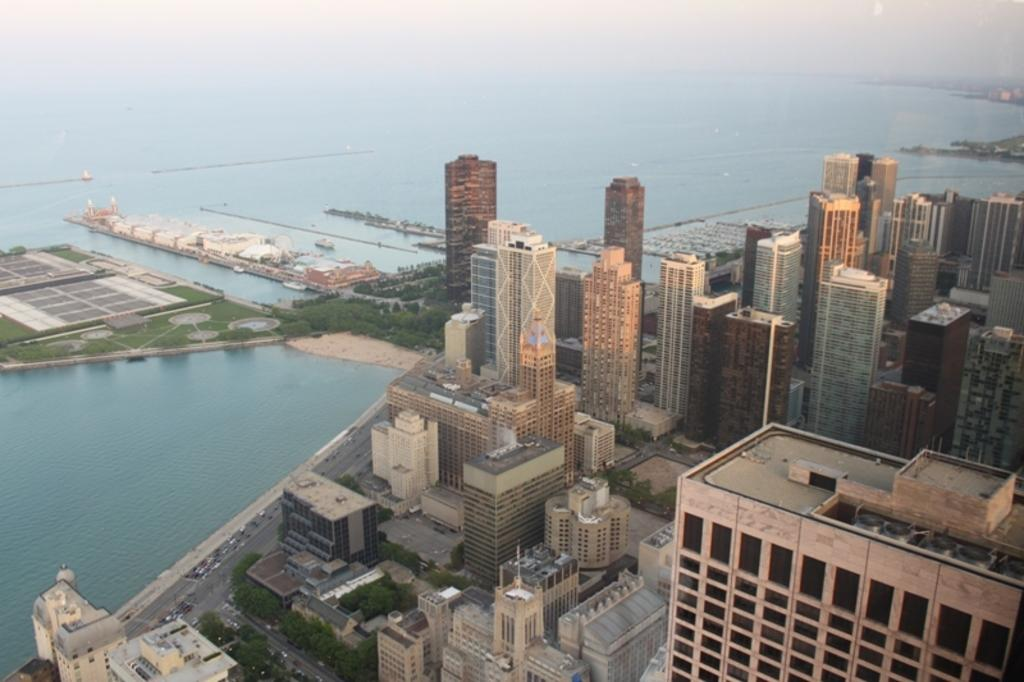What type of structures can be seen in the image? There are buildings in the image. What is the primary mode of transportation visible in the image? There are vehicles in the image. What natural elements can be seen in the image? There are trees and water visible in the image. What part of the natural environment is visible in the image? The sky is visible in the image. What type of soap is being used to clean the buildings in the image? There is no soap present in the image, and the buildings are not being cleaned. 